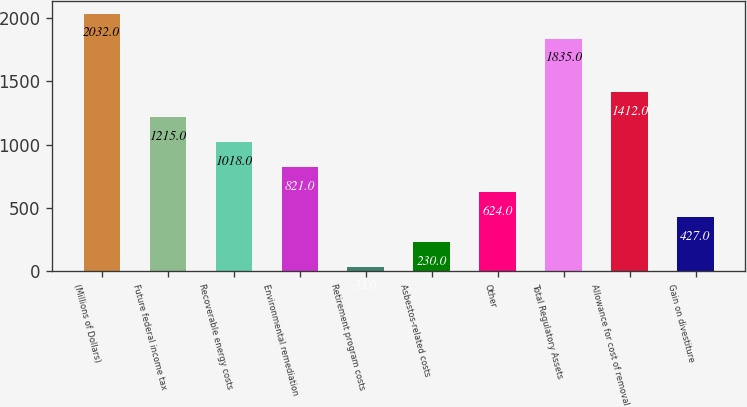<chart> <loc_0><loc_0><loc_500><loc_500><bar_chart><fcel>(Millions of Dollars)<fcel>Future federal income tax<fcel>Recoverable energy costs<fcel>Environmental remediation<fcel>Retirement program costs<fcel>Asbestos-related costs<fcel>Other<fcel>Total Regulatory Assets<fcel>Allowance for cost of removal<fcel>Gain on divestiture<nl><fcel>2032<fcel>1215<fcel>1018<fcel>821<fcel>33<fcel>230<fcel>624<fcel>1835<fcel>1412<fcel>427<nl></chart> 